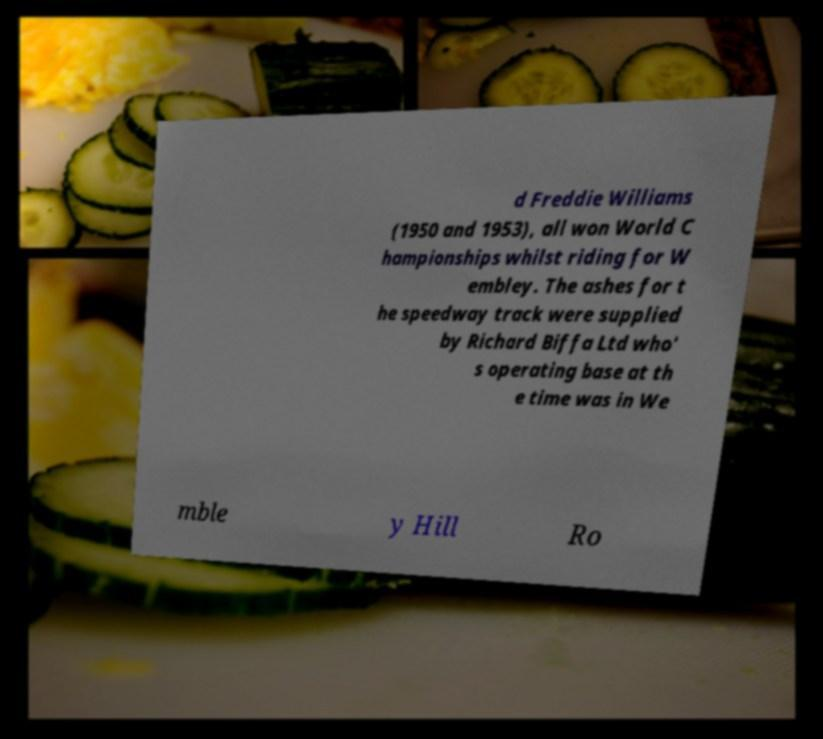There's text embedded in this image that I need extracted. Can you transcribe it verbatim? d Freddie Williams (1950 and 1953), all won World C hampionships whilst riding for W embley. The ashes for t he speedway track were supplied by Richard Biffa Ltd who' s operating base at th e time was in We mble y Hill Ro 